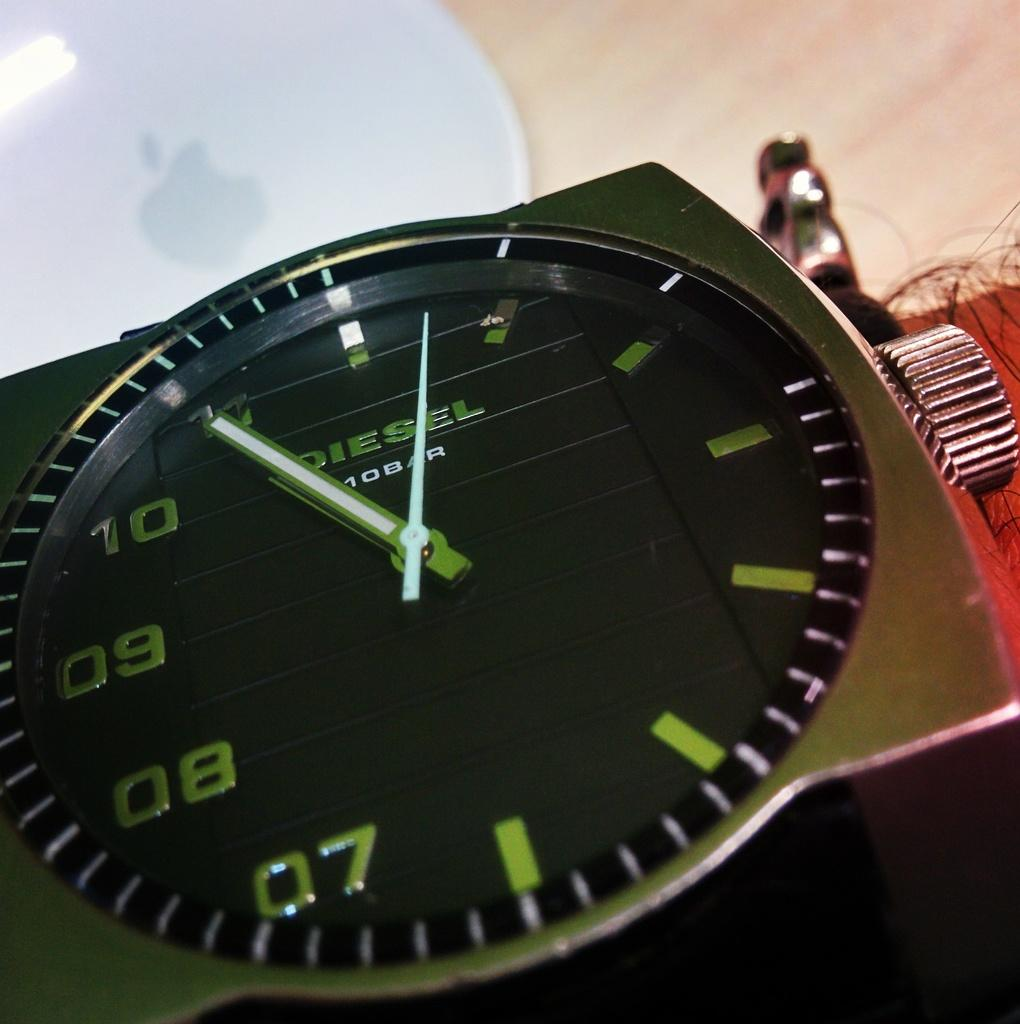<image>
Provide a brief description of the given image. A Diesel brand watch only has numbers on the left side of the face. 